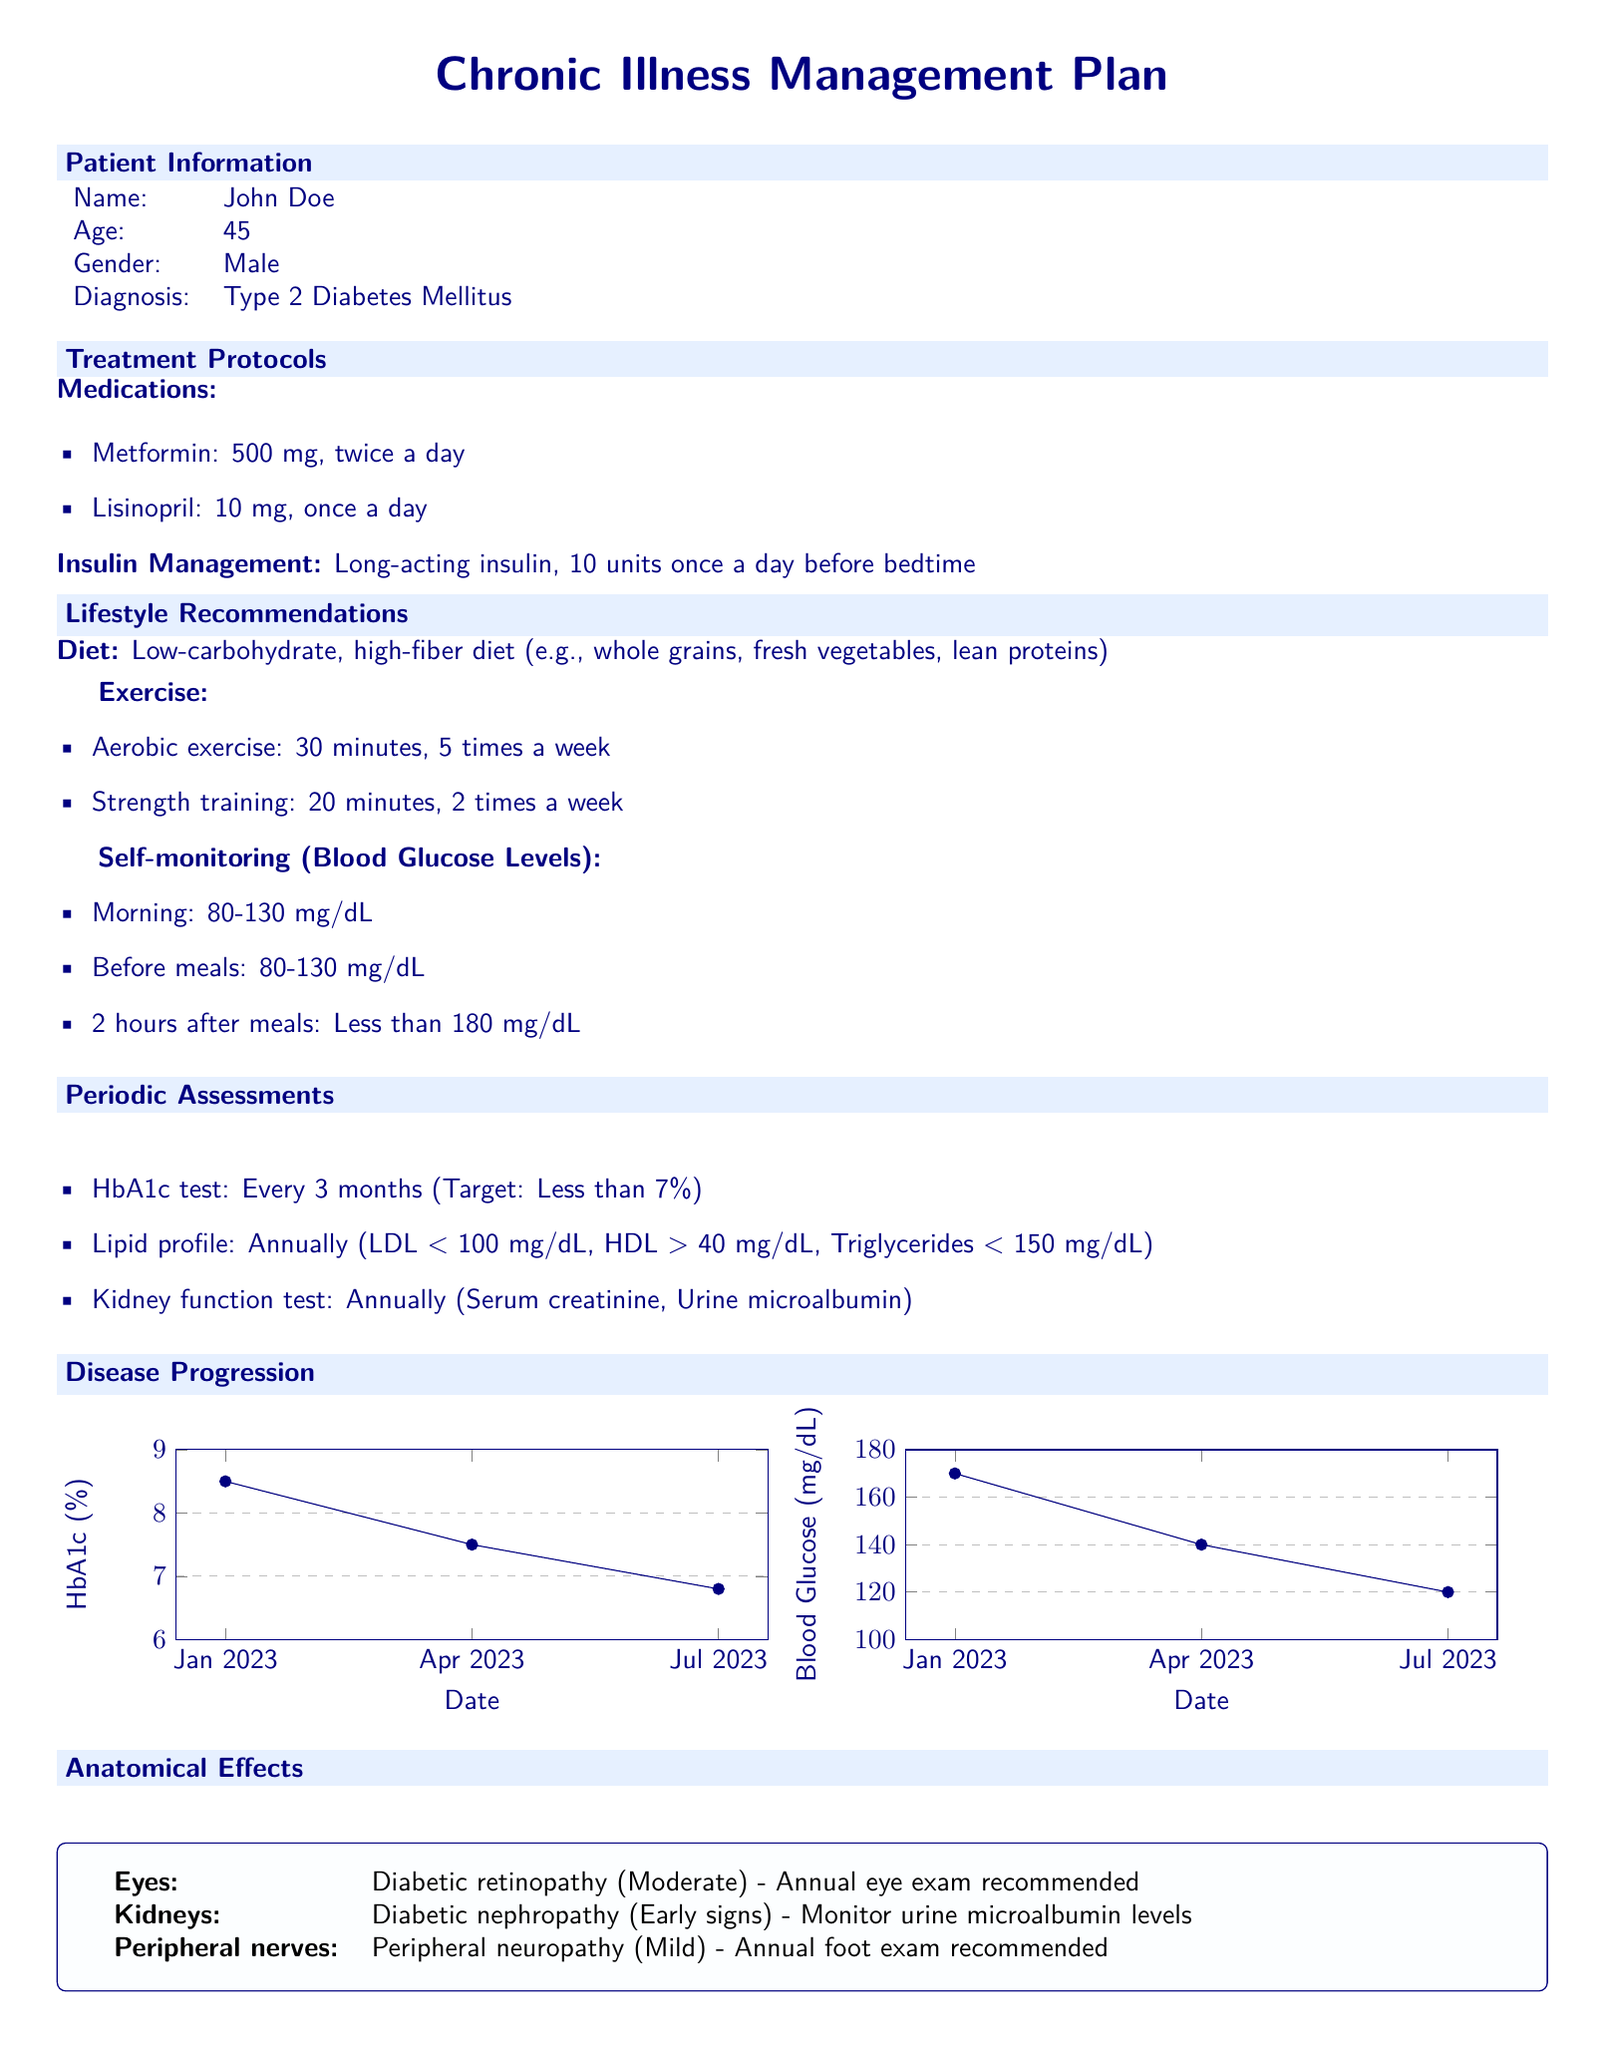What is the patient's age? The age of the patient, John Doe, is provided in the document under Patient Information.
Answer: 45 What is the medication dosage for Metformin? The document specifies the dosage of Metformin in the Treatment Protocols section.
Answer: 500 mg, twice a day How often should the HbA1c test be conducted? The frequency of the HbA1c test is outlined in the Periodic Assessments section.
Answer: Every 3 months What is the target HbA1c level? The target HbA1c level is stated in the Periodic Assessments section of the document.
Answer: Less than 7% What type of diet is recommended? The dietary recommendation is listed in the Lifestyle Recommendations section, indicating the kind of diet the patient should follow.
Answer: Low-carbohydrate, high-fiber diet What were the patient's blood glucose levels in July 2023? The blood glucose levels are shown in one of the charts displaying disease progression.
Answer: 120 mg/dL What anatomical effect is associated with the eyes? The document mentions anatomical effects related to diabetes, specifically in the Anatomical Effects section.
Answer: Diabetic retinopathy (Moderate) How many times a week should aerobic exercise be done? The Lifestyle Recommendations section outlines the exercise regimen, including frequency for aerobic exercise.
Answer: 5 times a week What is the recommended annual exam for diabetic nephropathy? The recommendation for monitoring diabetic nephropathy is mentioned in the Anatomical Effects section.
Answer: Monitor urine microalbumin levels 